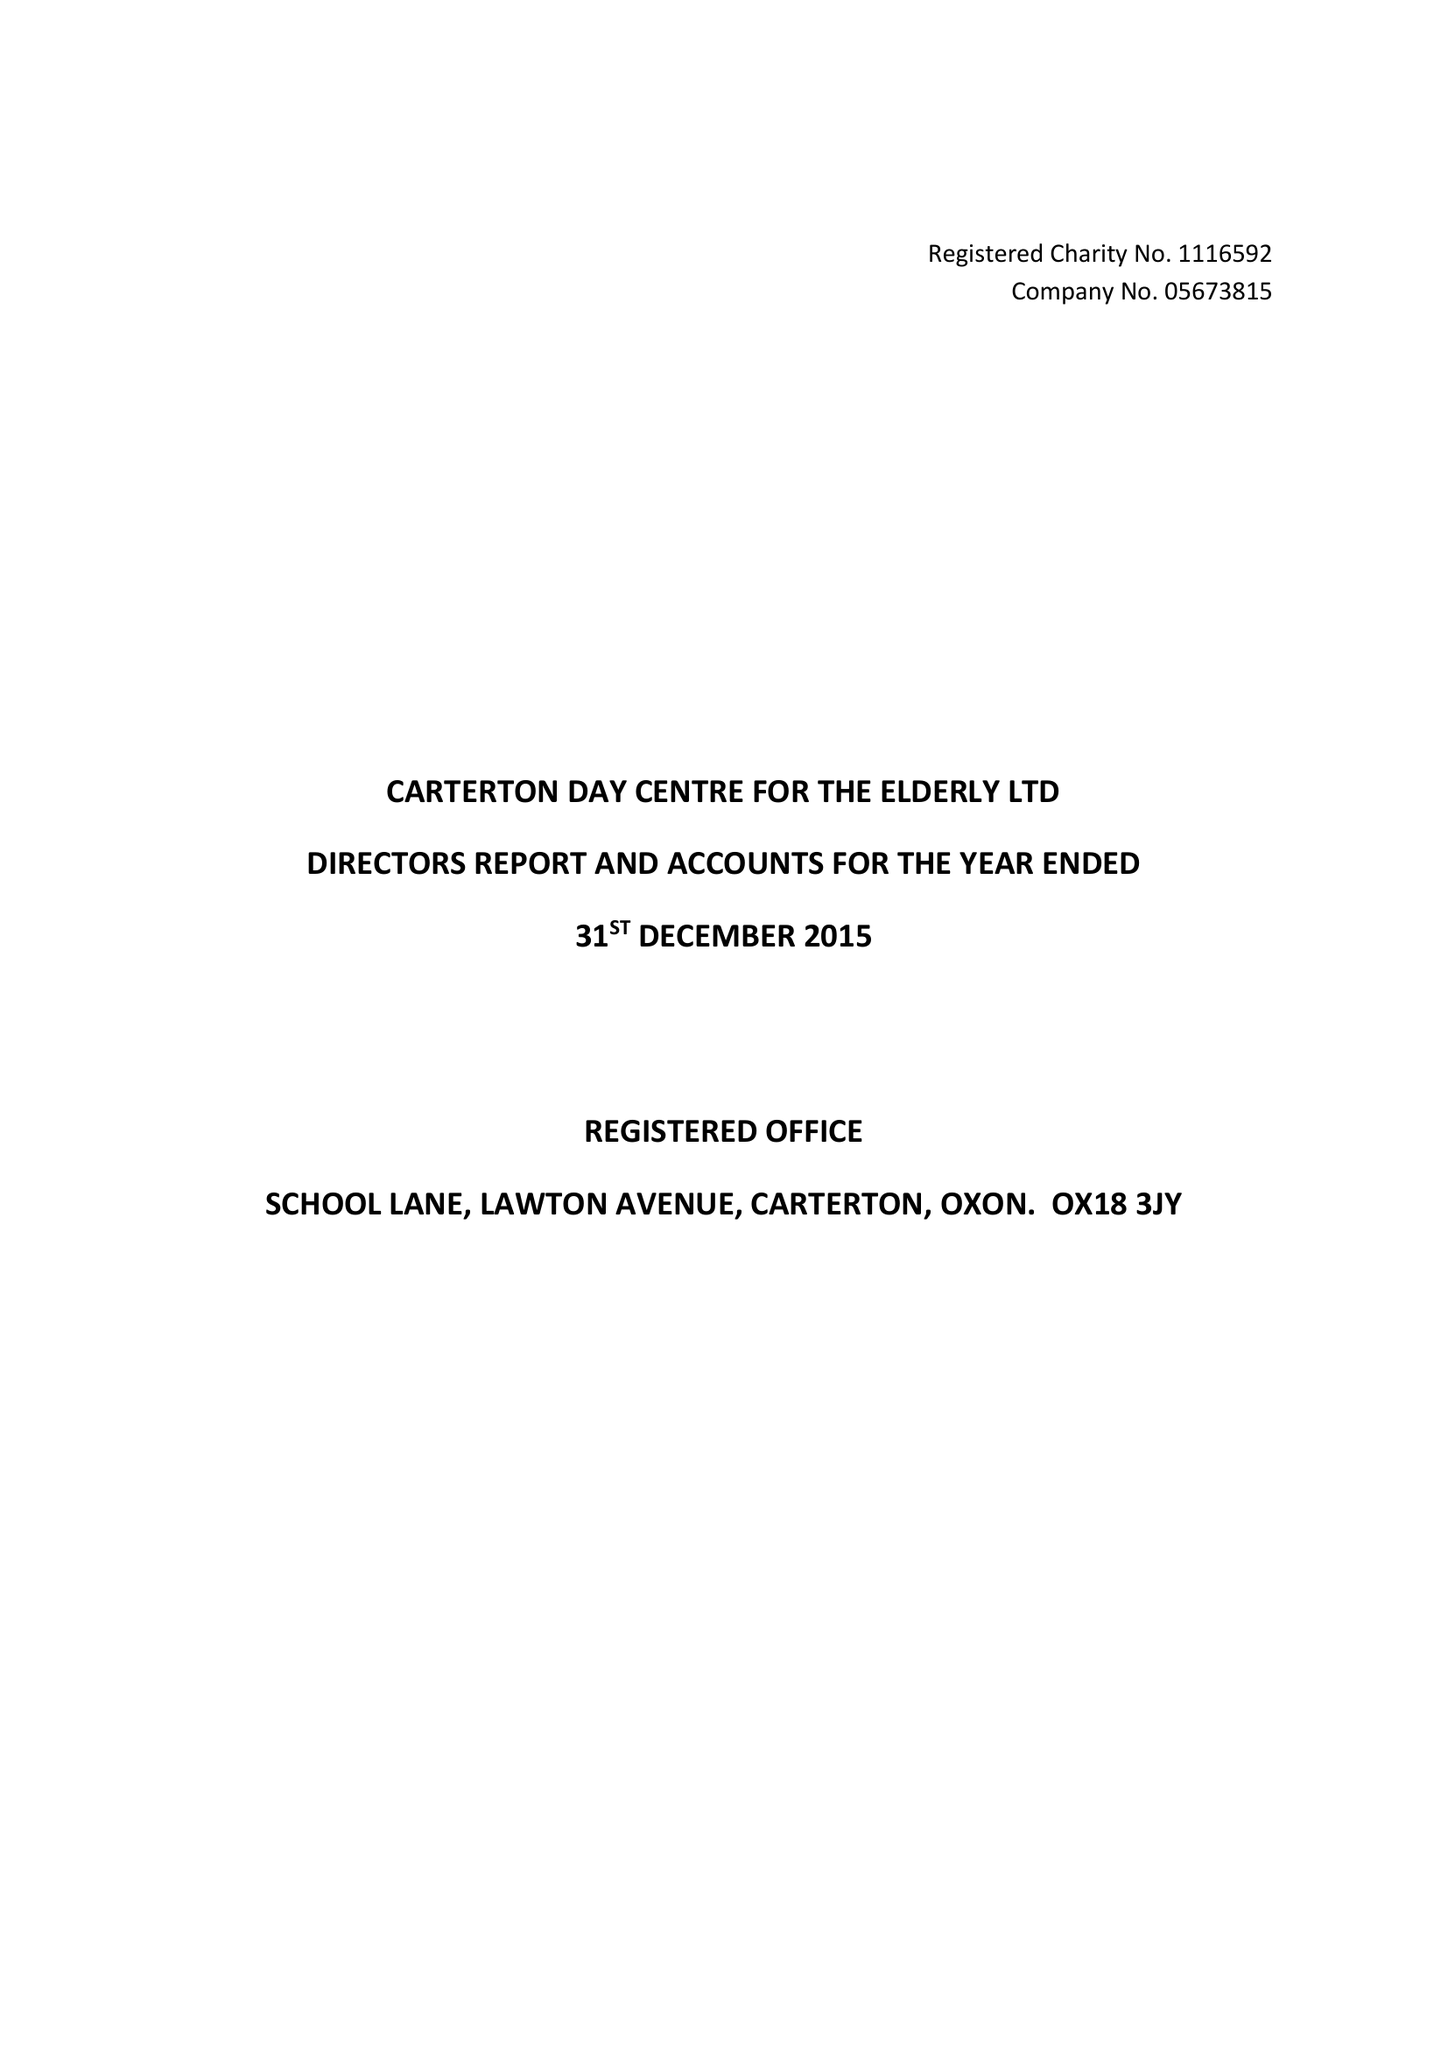What is the value for the address__postcode?
Answer the question using a single word or phrase. OX18 3JY 